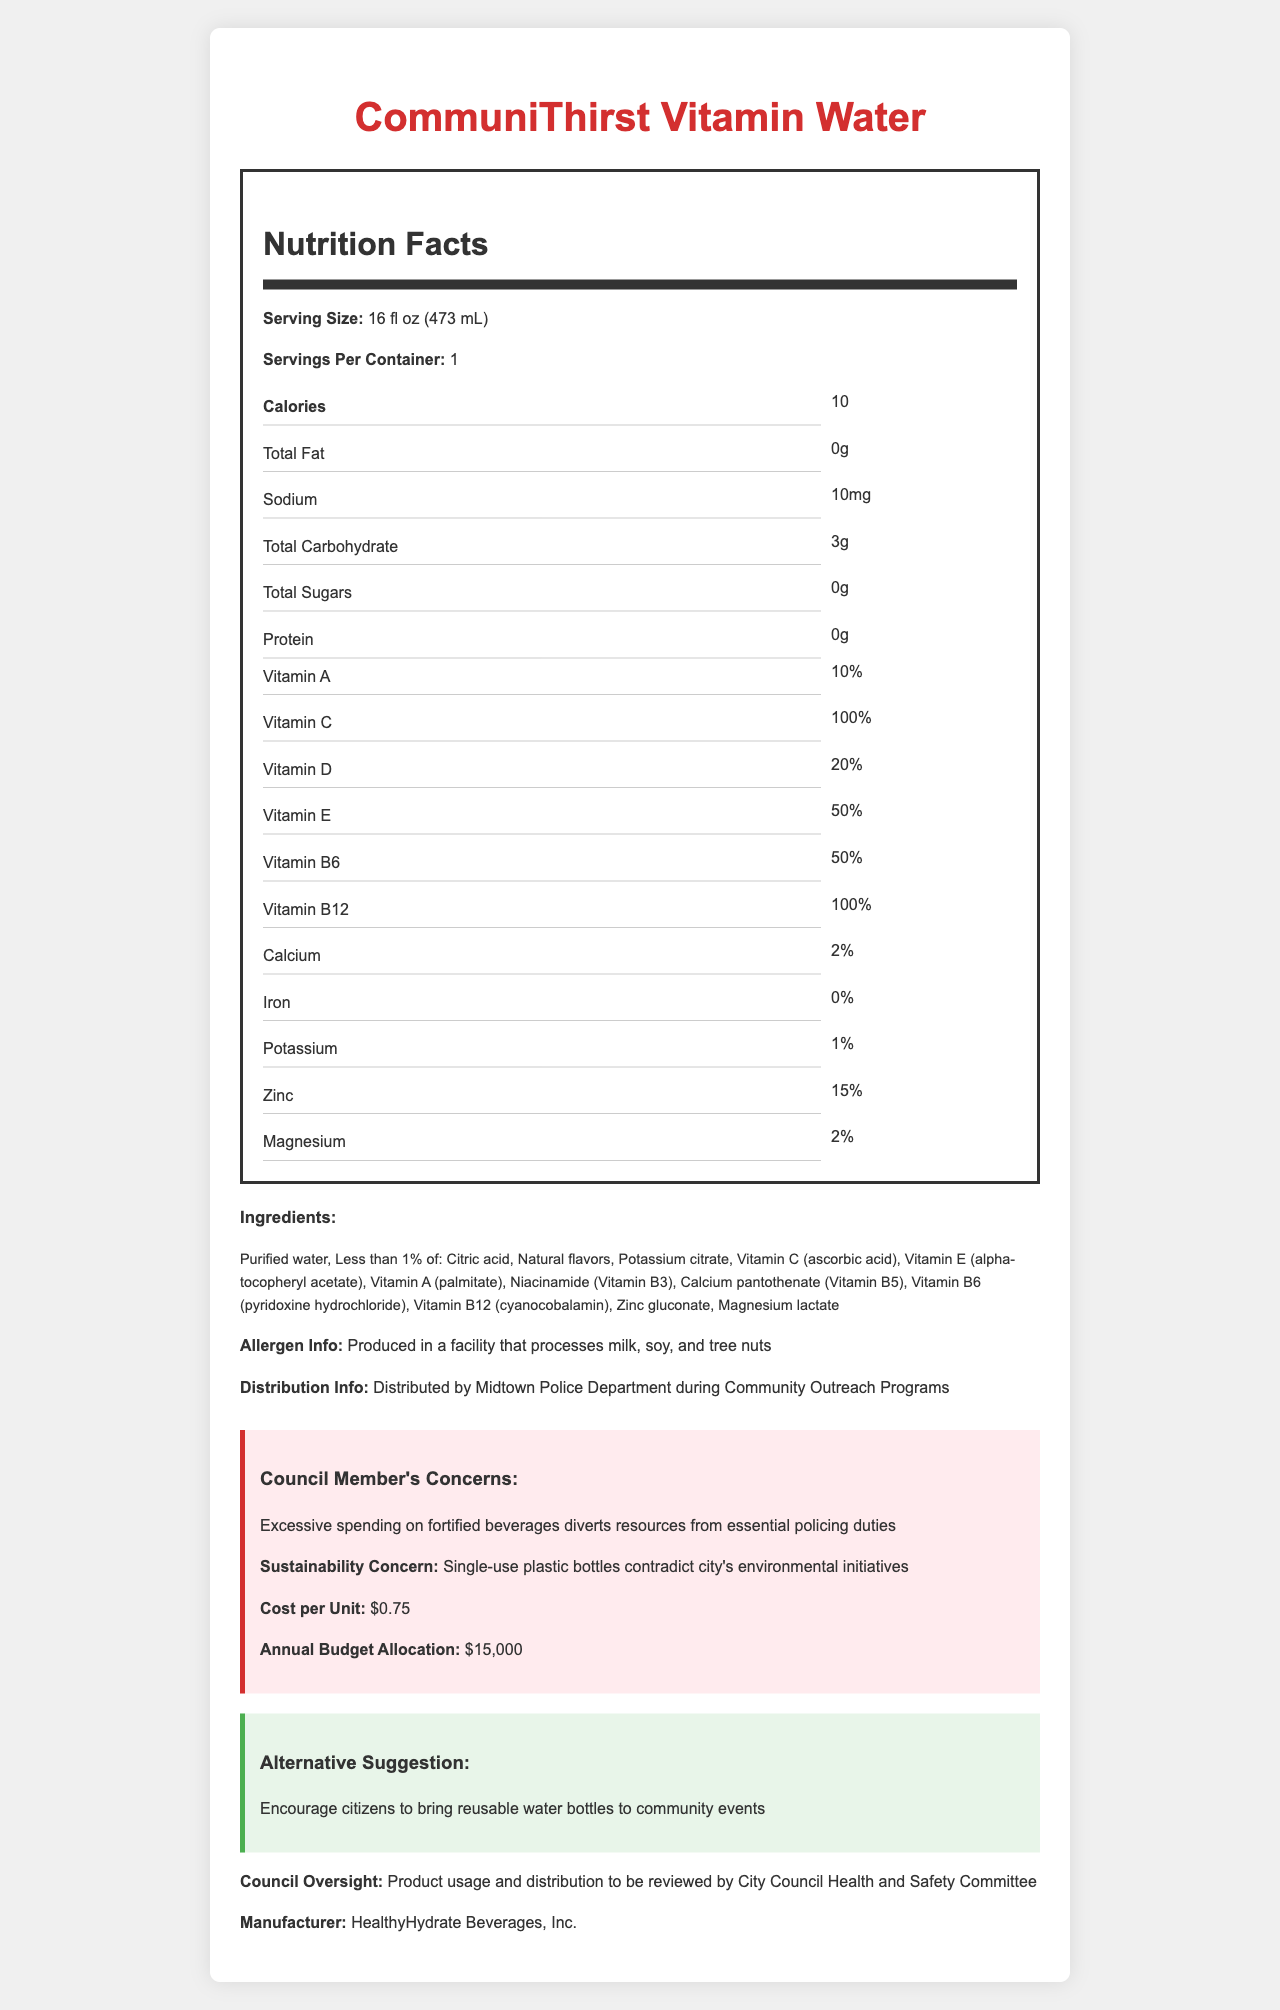what is the serving size? The serving size is listed at the beginning of the Nutrition Facts section as "16 fl oz (473 mL)".
Answer: 16 fl oz (473 mL) How much sodium is in one serving? The amount of sodium is listed in the Nutrition Facts under "Sodium" as "10mg".
Answer: 10mg List three vitamins present in the CommuniThirst Vitamin Water. The vitamins are listed under the Nutrition Facts section, where it mentions Vitamin A (10%), Vitamin C (100%), and Vitamin D (20%).
Answer: Vitamin A, Vitamin C, Vitamin D Who distributes the CommuniThirst Vitamin Water? The distribution information at the end of the document states it is "Distributed by Midtown Police Department during Community Outreach Programs".
Answer: Midtown Police Department What is the cost per unit of the beverage? The cost per unit is stated in the "Council Member's Concerns" section as "$0.75".
Answer: $0.75 How many total carbohydrates are in the beverage? The amount of total carbohydrates is listed under the Nutrition Facts as "3g".
Answer: 3g Which vitamin is present at the highest percentage of the daily value? A. Vitamin A B. Vitamin C C. Vitamin D D. Vitamin E According to the Nutrition Facts, Vitamin C is present at 100% daily value, which is the highest compared to the other listed vitamins.
Answer: B How many servings are there per container? A. 1 B. 2 C. 3 D. 4 The document states there are "1" serving per container.
Answer: A Are there any allergens in CommuniThirst Vitamin Water? (Yes/No) Although allergens are not in the ingredients, the document mentions it is "Produced in a facility that processes milk, soy, and tree nuts", indicating possible cross-contamination but not direct ingredients.
Answer: No Summarize the main concerns of the council regarding this beverage. The council's main concerns include excessive spending on fortified beverages which might divert resources from essential policing duties, the sustainability concern regarding single-use plastic bottles, and a suggestion to encourage citizens to bring reusable water bottles.
Answer: Excessive spending, sustainability issues, and resource allocation What is the annual budget allocation for the beverage program? The allocated budget is mentioned under the "Council Member's Concerns" section as "$15,000".
Answer: $15,000 Can we determine when the community policing events are held? The document provides details about the distribution and concerns but does not mention specific dates or times for the community policing events.
Answer: Cannot be determined 